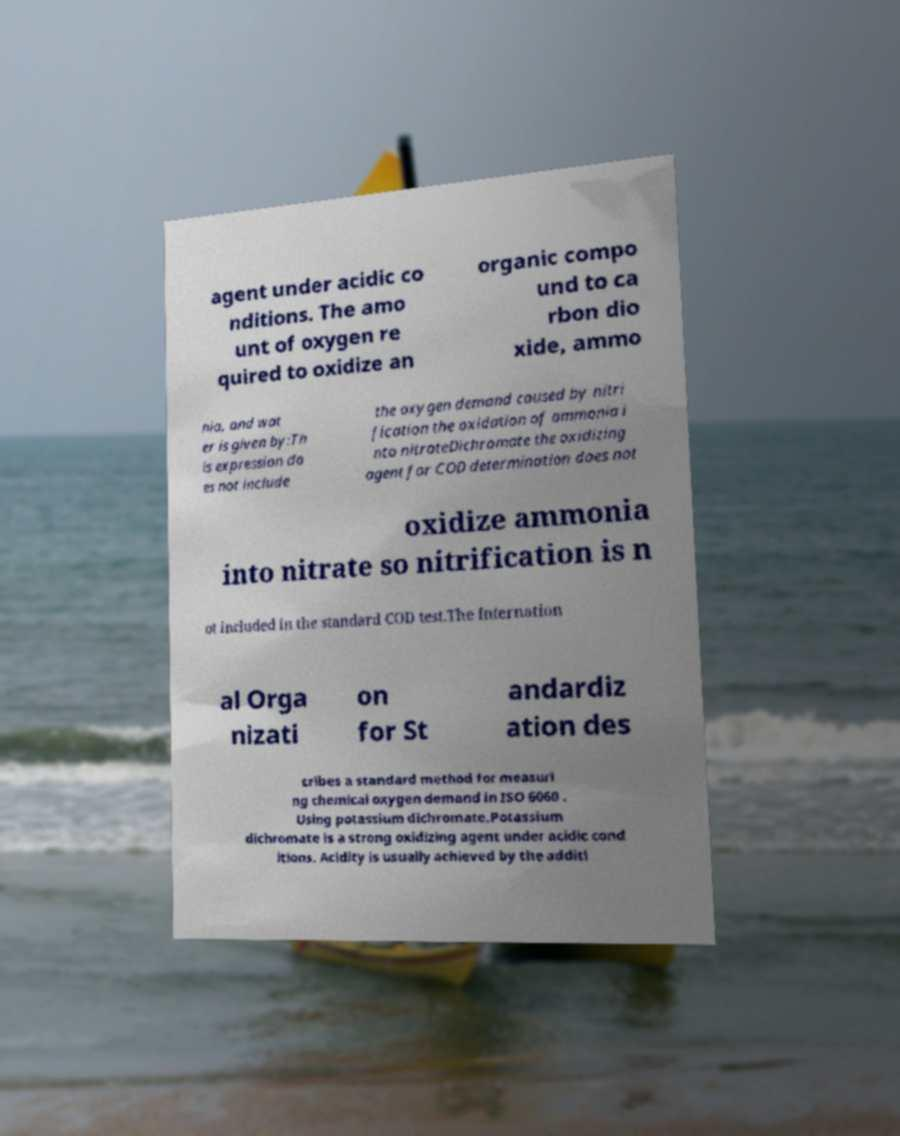I need the written content from this picture converted into text. Can you do that? agent under acidic co nditions. The amo unt of oxygen re quired to oxidize an organic compo und to ca rbon dio xide, ammo nia, and wat er is given by:Th is expression do es not include the oxygen demand caused by nitri fication the oxidation of ammonia i nto nitrateDichromate the oxidizing agent for COD determination does not oxidize ammonia into nitrate so nitrification is n ot included in the standard COD test.The Internation al Orga nizati on for St andardiz ation des cribes a standard method for measuri ng chemical oxygen demand in ISO 6060 . Using potassium dichromate.Potassium dichromate is a strong oxidizing agent under acidic cond itions. Acidity is usually achieved by the additi 